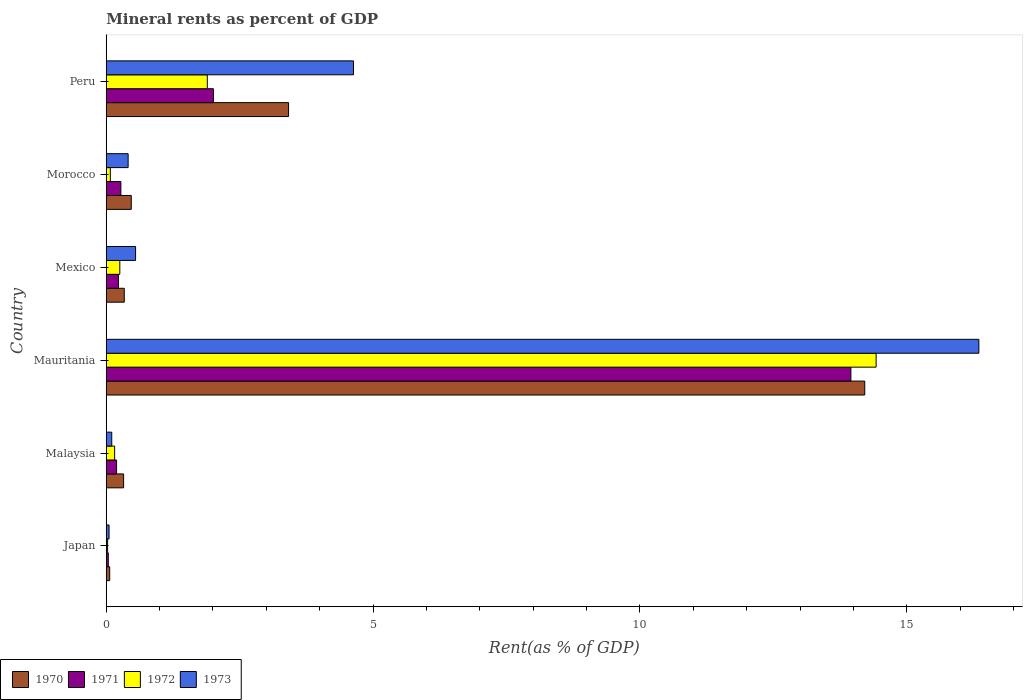Are the number of bars on each tick of the Y-axis equal?
Keep it short and to the point. Yes. How many bars are there on the 3rd tick from the top?
Ensure brevity in your answer.  4. How many bars are there on the 1st tick from the bottom?
Your answer should be very brief. 4. What is the label of the 4th group of bars from the top?
Provide a short and direct response. Mauritania. In how many cases, is the number of bars for a given country not equal to the number of legend labels?
Ensure brevity in your answer.  0. What is the mineral rent in 1972 in Mauritania?
Offer a terse response. 14.43. Across all countries, what is the maximum mineral rent in 1970?
Offer a very short reply. 14.21. Across all countries, what is the minimum mineral rent in 1971?
Make the answer very short. 0.04. In which country was the mineral rent in 1973 maximum?
Your answer should be very brief. Mauritania. What is the total mineral rent in 1971 in the graph?
Your answer should be compact. 16.7. What is the difference between the mineral rent in 1970 in Mauritania and that in Peru?
Your answer should be very brief. 10.8. What is the difference between the mineral rent in 1970 in Mauritania and the mineral rent in 1972 in Mexico?
Offer a terse response. 13.96. What is the average mineral rent in 1973 per country?
Provide a short and direct response. 3.68. What is the difference between the mineral rent in 1973 and mineral rent in 1972 in Mauritania?
Ensure brevity in your answer.  1.93. In how many countries, is the mineral rent in 1971 greater than 3 %?
Offer a terse response. 1. What is the ratio of the mineral rent in 1972 in Morocco to that in Peru?
Offer a very short reply. 0.04. Is the difference between the mineral rent in 1973 in Japan and Peru greater than the difference between the mineral rent in 1972 in Japan and Peru?
Give a very brief answer. No. What is the difference between the highest and the second highest mineral rent in 1971?
Your response must be concise. 11.94. What is the difference between the highest and the lowest mineral rent in 1972?
Your answer should be compact. 14.4. In how many countries, is the mineral rent in 1971 greater than the average mineral rent in 1971 taken over all countries?
Your response must be concise. 1. Is the sum of the mineral rent in 1971 in Mauritania and Peru greater than the maximum mineral rent in 1970 across all countries?
Offer a terse response. Yes. Is it the case that in every country, the sum of the mineral rent in 1972 and mineral rent in 1970 is greater than the sum of mineral rent in 1973 and mineral rent in 1971?
Make the answer very short. No. What does the 4th bar from the bottom in Mexico represents?
Your response must be concise. 1973. Are all the bars in the graph horizontal?
Offer a terse response. Yes. What is the difference between two consecutive major ticks on the X-axis?
Make the answer very short. 5. Does the graph contain grids?
Offer a terse response. No. What is the title of the graph?
Your answer should be very brief. Mineral rents as percent of GDP. Does "1977" appear as one of the legend labels in the graph?
Provide a short and direct response. No. What is the label or title of the X-axis?
Provide a short and direct response. Rent(as % of GDP). What is the label or title of the Y-axis?
Provide a short and direct response. Country. What is the Rent(as % of GDP) of 1970 in Japan?
Keep it short and to the point. 0.06. What is the Rent(as % of GDP) of 1971 in Japan?
Make the answer very short. 0.04. What is the Rent(as % of GDP) in 1972 in Japan?
Make the answer very short. 0.03. What is the Rent(as % of GDP) of 1973 in Japan?
Keep it short and to the point. 0.05. What is the Rent(as % of GDP) of 1970 in Malaysia?
Ensure brevity in your answer.  0.33. What is the Rent(as % of GDP) of 1971 in Malaysia?
Provide a short and direct response. 0.19. What is the Rent(as % of GDP) in 1972 in Malaysia?
Your answer should be compact. 0.16. What is the Rent(as % of GDP) in 1973 in Malaysia?
Offer a terse response. 0.1. What is the Rent(as % of GDP) of 1970 in Mauritania?
Offer a very short reply. 14.21. What is the Rent(as % of GDP) of 1971 in Mauritania?
Make the answer very short. 13.95. What is the Rent(as % of GDP) in 1972 in Mauritania?
Make the answer very short. 14.43. What is the Rent(as % of GDP) of 1973 in Mauritania?
Give a very brief answer. 16.35. What is the Rent(as % of GDP) of 1970 in Mexico?
Provide a succinct answer. 0.34. What is the Rent(as % of GDP) in 1971 in Mexico?
Your response must be concise. 0.23. What is the Rent(as % of GDP) of 1972 in Mexico?
Your answer should be compact. 0.25. What is the Rent(as % of GDP) of 1973 in Mexico?
Make the answer very short. 0.55. What is the Rent(as % of GDP) of 1970 in Morocco?
Your answer should be compact. 0.47. What is the Rent(as % of GDP) of 1971 in Morocco?
Keep it short and to the point. 0.27. What is the Rent(as % of GDP) of 1972 in Morocco?
Your answer should be very brief. 0.08. What is the Rent(as % of GDP) in 1973 in Morocco?
Offer a terse response. 0.41. What is the Rent(as % of GDP) of 1970 in Peru?
Give a very brief answer. 3.42. What is the Rent(as % of GDP) of 1971 in Peru?
Provide a succinct answer. 2.01. What is the Rent(as % of GDP) of 1972 in Peru?
Your answer should be very brief. 1.89. What is the Rent(as % of GDP) of 1973 in Peru?
Your answer should be compact. 4.63. Across all countries, what is the maximum Rent(as % of GDP) in 1970?
Keep it short and to the point. 14.21. Across all countries, what is the maximum Rent(as % of GDP) in 1971?
Provide a succinct answer. 13.95. Across all countries, what is the maximum Rent(as % of GDP) in 1972?
Keep it short and to the point. 14.43. Across all countries, what is the maximum Rent(as % of GDP) in 1973?
Provide a short and direct response. 16.35. Across all countries, what is the minimum Rent(as % of GDP) of 1970?
Your answer should be very brief. 0.06. Across all countries, what is the minimum Rent(as % of GDP) in 1971?
Your response must be concise. 0.04. Across all countries, what is the minimum Rent(as % of GDP) of 1972?
Provide a succinct answer. 0.03. Across all countries, what is the minimum Rent(as % of GDP) in 1973?
Your response must be concise. 0.05. What is the total Rent(as % of GDP) of 1970 in the graph?
Offer a terse response. 18.83. What is the total Rent(as % of GDP) in 1971 in the graph?
Your answer should be very brief. 16.7. What is the total Rent(as % of GDP) in 1972 in the graph?
Offer a very short reply. 16.83. What is the total Rent(as % of GDP) in 1973 in the graph?
Your response must be concise. 22.1. What is the difference between the Rent(as % of GDP) of 1970 in Japan and that in Malaysia?
Offer a very short reply. -0.26. What is the difference between the Rent(as % of GDP) in 1971 in Japan and that in Malaysia?
Your answer should be compact. -0.16. What is the difference between the Rent(as % of GDP) of 1972 in Japan and that in Malaysia?
Your response must be concise. -0.13. What is the difference between the Rent(as % of GDP) in 1973 in Japan and that in Malaysia?
Give a very brief answer. -0.05. What is the difference between the Rent(as % of GDP) of 1970 in Japan and that in Mauritania?
Your answer should be very brief. -14.15. What is the difference between the Rent(as % of GDP) of 1971 in Japan and that in Mauritania?
Your response must be concise. -13.91. What is the difference between the Rent(as % of GDP) in 1972 in Japan and that in Mauritania?
Your response must be concise. -14.4. What is the difference between the Rent(as % of GDP) in 1973 in Japan and that in Mauritania?
Your answer should be very brief. -16.3. What is the difference between the Rent(as % of GDP) in 1970 in Japan and that in Mexico?
Your answer should be very brief. -0.27. What is the difference between the Rent(as % of GDP) in 1971 in Japan and that in Mexico?
Offer a terse response. -0.19. What is the difference between the Rent(as % of GDP) of 1972 in Japan and that in Mexico?
Provide a short and direct response. -0.23. What is the difference between the Rent(as % of GDP) in 1973 in Japan and that in Mexico?
Your answer should be very brief. -0.5. What is the difference between the Rent(as % of GDP) in 1970 in Japan and that in Morocco?
Make the answer very short. -0.4. What is the difference between the Rent(as % of GDP) in 1971 in Japan and that in Morocco?
Keep it short and to the point. -0.24. What is the difference between the Rent(as % of GDP) of 1972 in Japan and that in Morocco?
Provide a succinct answer. -0.05. What is the difference between the Rent(as % of GDP) in 1973 in Japan and that in Morocco?
Keep it short and to the point. -0.36. What is the difference between the Rent(as % of GDP) in 1970 in Japan and that in Peru?
Your answer should be very brief. -3.35. What is the difference between the Rent(as % of GDP) in 1971 in Japan and that in Peru?
Your answer should be compact. -1.97. What is the difference between the Rent(as % of GDP) of 1972 in Japan and that in Peru?
Your answer should be compact. -1.87. What is the difference between the Rent(as % of GDP) in 1973 in Japan and that in Peru?
Provide a succinct answer. -4.58. What is the difference between the Rent(as % of GDP) in 1970 in Malaysia and that in Mauritania?
Your response must be concise. -13.89. What is the difference between the Rent(as % of GDP) of 1971 in Malaysia and that in Mauritania?
Offer a very short reply. -13.76. What is the difference between the Rent(as % of GDP) of 1972 in Malaysia and that in Mauritania?
Ensure brevity in your answer.  -14.27. What is the difference between the Rent(as % of GDP) of 1973 in Malaysia and that in Mauritania?
Your response must be concise. -16.25. What is the difference between the Rent(as % of GDP) in 1970 in Malaysia and that in Mexico?
Ensure brevity in your answer.  -0.01. What is the difference between the Rent(as % of GDP) of 1971 in Malaysia and that in Mexico?
Your answer should be compact. -0.03. What is the difference between the Rent(as % of GDP) of 1972 in Malaysia and that in Mexico?
Keep it short and to the point. -0.1. What is the difference between the Rent(as % of GDP) of 1973 in Malaysia and that in Mexico?
Provide a succinct answer. -0.45. What is the difference between the Rent(as % of GDP) of 1970 in Malaysia and that in Morocco?
Give a very brief answer. -0.14. What is the difference between the Rent(as % of GDP) in 1971 in Malaysia and that in Morocco?
Offer a very short reply. -0.08. What is the difference between the Rent(as % of GDP) of 1972 in Malaysia and that in Morocco?
Your answer should be very brief. 0.08. What is the difference between the Rent(as % of GDP) of 1973 in Malaysia and that in Morocco?
Your response must be concise. -0.31. What is the difference between the Rent(as % of GDP) of 1970 in Malaysia and that in Peru?
Provide a succinct answer. -3.09. What is the difference between the Rent(as % of GDP) in 1971 in Malaysia and that in Peru?
Provide a short and direct response. -1.81. What is the difference between the Rent(as % of GDP) of 1972 in Malaysia and that in Peru?
Ensure brevity in your answer.  -1.74. What is the difference between the Rent(as % of GDP) of 1973 in Malaysia and that in Peru?
Ensure brevity in your answer.  -4.53. What is the difference between the Rent(as % of GDP) of 1970 in Mauritania and that in Mexico?
Give a very brief answer. 13.88. What is the difference between the Rent(as % of GDP) in 1971 in Mauritania and that in Mexico?
Your answer should be compact. 13.72. What is the difference between the Rent(as % of GDP) of 1972 in Mauritania and that in Mexico?
Your answer should be very brief. 14.17. What is the difference between the Rent(as % of GDP) in 1973 in Mauritania and that in Mexico?
Offer a terse response. 15.8. What is the difference between the Rent(as % of GDP) in 1970 in Mauritania and that in Morocco?
Provide a succinct answer. 13.74. What is the difference between the Rent(as % of GDP) in 1971 in Mauritania and that in Morocco?
Ensure brevity in your answer.  13.68. What is the difference between the Rent(as % of GDP) in 1972 in Mauritania and that in Morocco?
Your answer should be compact. 14.35. What is the difference between the Rent(as % of GDP) of 1973 in Mauritania and that in Morocco?
Your answer should be very brief. 15.94. What is the difference between the Rent(as % of GDP) of 1970 in Mauritania and that in Peru?
Your answer should be very brief. 10.8. What is the difference between the Rent(as % of GDP) in 1971 in Mauritania and that in Peru?
Your answer should be compact. 11.94. What is the difference between the Rent(as % of GDP) in 1972 in Mauritania and that in Peru?
Offer a very short reply. 12.53. What is the difference between the Rent(as % of GDP) in 1973 in Mauritania and that in Peru?
Ensure brevity in your answer.  11.72. What is the difference between the Rent(as % of GDP) in 1970 in Mexico and that in Morocco?
Offer a terse response. -0.13. What is the difference between the Rent(as % of GDP) of 1971 in Mexico and that in Morocco?
Your response must be concise. -0.05. What is the difference between the Rent(as % of GDP) of 1972 in Mexico and that in Morocco?
Offer a terse response. 0.18. What is the difference between the Rent(as % of GDP) of 1973 in Mexico and that in Morocco?
Your answer should be very brief. 0.14. What is the difference between the Rent(as % of GDP) of 1970 in Mexico and that in Peru?
Provide a succinct answer. -3.08. What is the difference between the Rent(as % of GDP) in 1971 in Mexico and that in Peru?
Offer a terse response. -1.78. What is the difference between the Rent(as % of GDP) of 1972 in Mexico and that in Peru?
Give a very brief answer. -1.64. What is the difference between the Rent(as % of GDP) of 1973 in Mexico and that in Peru?
Make the answer very short. -4.08. What is the difference between the Rent(as % of GDP) in 1970 in Morocco and that in Peru?
Provide a succinct answer. -2.95. What is the difference between the Rent(as % of GDP) of 1971 in Morocco and that in Peru?
Give a very brief answer. -1.73. What is the difference between the Rent(as % of GDP) in 1972 in Morocco and that in Peru?
Your response must be concise. -1.82. What is the difference between the Rent(as % of GDP) in 1973 in Morocco and that in Peru?
Keep it short and to the point. -4.22. What is the difference between the Rent(as % of GDP) in 1970 in Japan and the Rent(as % of GDP) in 1971 in Malaysia?
Offer a very short reply. -0.13. What is the difference between the Rent(as % of GDP) in 1970 in Japan and the Rent(as % of GDP) in 1972 in Malaysia?
Your answer should be very brief. -0.09. What is the difference between the Rent(as % of GDP) in 1970 in Japan and the Rent(as % of GDP) in 1973 in Malaysia?
Your response must be concise. -0.04. What is the difference between the Rent(as % of GDP) in 1971 in Japan and the Rent(as % of GDP) in 1972 in Malaysia?
Provide a succinct answer. -0.12. What is the difference between the Rent(as % of GDP) of 1971 in Japan and the Rent(as % of GDP) of 1973 in Malaysia?
Provide a succinct answer. -0.06. What is the difference between the Rent(as % of GDP) of 1972 in Japan and the Rent(as % of GDP) of 1973 in Malaysia?
Give a very brief answer. -0.08. What is the difference between the Rent(as % of GDP) of 1970 in Japan and the Rent(as % of GDP) of 1971 in Mauritania?
Make the answer very short. -13.89. What is the difference between the Rent(as % of GDP) of 1970 in Japan and the Rent(as % of GDP) of 1972 in Mauritania?
Make the answer very short. -14.36. What is the difference between the Rent(as % of GDP) of 1970 in Japan and the Rent(as % of GDP) of 1973 in Mauritania?
Give a very brief answer. -16.29. What is the difference between the Rent(as % of GDP) in 1971 in Japan and the Rent(as % of GDP) in 1972 in Mauritania?
Offer a very short reply. -14.39. What is the difference between the Rent(as % of GDP) in 1971 in Japan and the Rent(as % of GDP) in 1973 in Mauritania?
Your answer should be compact. -16.31. What is the difference between the Rent(as % of GDP) of 1972 in Japan and the Rent(as % of GDP) of 1973 in Mauritania?
Ensure brevity in your answer.  -16.33. What is the difference between the Rent(as % of GDP) in 1970 in Japan and the Rent(as % of GDP) in 1971 in Mexico?
Your response must be concise. -0.16. What is the difference between the Rent(as % of GDP) in 1970 in Japan and the Rent(as % of GDP) in 1972 in Mexico?
Your response must be concise. -0.19. What is the difference between the Rent(as % of GDP) of 1970 in Japan and the Rent(as % of GDP) of 1973 in Mexico?
Your response must be concise. -0.48. What is the difference between the Rent(as % of GDP) in 1971 in Japan and the Rent(as % of GDP) in 1972 in Mexico?
Provide a succinct answer. -0.22. What is the difference between the Rent(as % of GDP) of 1971 in Japan and the Rent(as % of GDP) of 1973 in Mexico?
Offer a terse response. -0.51. What is the difference between the Rent(as % of GDP) in 1972 in Japan and the Rent(as % of GDP) in 1973 in Mexico?
Keep it short and to the point. -0.52. What is the difference between the Rent(as % of GDP) of 1970 in Japan and the Rent(as % of GDP) of 1971 in Morocco?
Give a very brief answer. -0.21. What is the difference between the Rent(as % of GDP) of 1970 in Japan and the Rent(as % of GDP) of 1972 in Morocco?
Provide a short and direct response. -0.01. What is the difference between the Rent(as % of GDP) of 1970 in Japan and the Rent(as % of GDP) of 1973 in Morocco?
Your response must be concise. -0.35. What is the difference between the Rent(as % of GDP) of 1971 in Japan and the Rent(as % of GDP) of 1972 in Morocco?
Provide a short and direct response. -0.04. What is the difference between the Rent(as % of GDP) of 1971 in Japan and the Rent(as % of GDP) of 1973 in Morocco?
Provide a succinct answer. -0.37. What is the difference between the Rent(as % of GDP) in 1972 in Japan and the Rent(as % of GDP) in 1973 in Morocco?
Provide a succinct answer. -0.39. What is the difference between the Rent(as % of GDP) in 1970 in Japan and the Rent(as % of GDP) in 1971 in Peru?
Make the answer very short. -1.94. What is the difference between the Rent(as % of GDP) of 1970 in Japan and the Rent(as % of GDP) of 1972 in Peru?
Offer a terse response. -1.83. What is the difference between the Rent(as % of GDP) in 1970 in Japan and the Rent(as % of GDP) in 1973 in Peru?
Provide a succinct answer. -4.57. What is the difference between the Rent(as % of GDP) in 1971 in Japan and the Rent(as % of GDP) in 1972 in Peru?
Your response must be concise. -1.86. What is the difference between the Rent(as % of GDP) in 1971 in Japan and the Rent(as % of GDP) in 1973 in Peru?
Keep it short and to the point. -4.59. What is the difference between the Rent(as % of GDP) of 1972 in Japan and the Rent(as % of GDP) of 1973 in Peru?
Your response must be concise. -4.61. What is the difference between the Rent(as % of GDP) of 1970 in Malaysia and the Rent(as % of GDP) of 1971 in Mauritania?
Offer a terse response. -13.63. What is the difference between the Rent(as % of GDP) in 1970 in Malaysia and the Rent(as % of GDP) in 1972 in Mauritania?
Your response must be concise. -14.1. What is the difference between the Rent(as % of GDP) of 1970 in Malaysia and the Rent(as % of GDP) of 1973 in Mauritania?
Offer a very short reply. -16.03. What is the difference between the Rent(as % of GDP) of 1971 in Malaysia and the Rent(as % of GDP) of 1972 in Mauritania?
Make the answer very short. -14.23. What is the difference between the Rent(as % of GDP) of 1971 in Malaysia and the Rent(as % of GDP) of 1973 in Mauritania?
Keep it short and to the point. -16.16. What is the difference between the Rent(as % of GDP) of 1972 in Malaysia and the Rent(as % of GDP) of 1973 in Mauritania?
Your answer should be very brief. -16.19. What is the difference between the Rent(as % of GDP) in 1970 in Malaysia and the Rent(as % of GDP) in 1971 in Mexico?
Ensure brevity in your answer.  0.1. What is the difference between the Rent(as % of GDP) of 1970 in Malaysia and the Rent(as % of GDP) of 1972 in Mexico?
Your response must be concise. 0.07. What is the difference between the Rent(as % of GDP) in 1970 in Malaysia and the Rent(as % of GDP) in 1973 in Mexico?
Ensure brevity in your answer.  -0.22. What is the difference between the Rent(as % of GDP) of 1971 in Malaysia and the Rent(as % of GDP) of 1972 in Mexico?
Offer a very short reply. -0.06. What is the difference between the Rent(as % of GDP) of 1971 in Malaysia and the Rent(as % of GDP) of 1973 in Mexico?
Your response must be concise. -0.36. What is the difference between the Rent(as % of GDP) in 1972 in Malaysia and the Rent(as % of GDP) in 1973 in Mexico?
Give a very brief answer. -0.39. What is the difference between the Rent(as % of GDP) of 1970 in Malaysia and the Rent(as % of GDP) of 1971 in Morocco?
Offer a terse response. 0.05. What is the difference between the Rent(as % of GDP) of 1970 in Malaysia and the Rent(as % of GDP) of 1972 in Morocco?
Your answer should be very brief. 0.25. What is the difference between the Rent(as % of GDP) of 1970 in Malaysia and the Rent(as % of GDP) of 1973 in Morocco?
Ensure brevity in your answer.  -0.09. What is the difference between the Rent(as % of GDP) in 1971 in Malaysia and the Rent(as % of GDP) in 1972 in Morocco?
Provide a short and direct response. 0.12. What is the difference between the Rent(as % of GDP) of 1971 in Malaysia and the Rent(as % of GDP) of 1973 in Morocco?
Give a very brief answer. -0.22. What is the difference between the Rent(as % of GDP) in 1972 in Malaysia and the Rent(as % of GDP) in 1973 in Morocco?
Your answer should be very brief. -0.25. What is the difference between the Rent(as % of GDP) in 1970 in Malaysia and the Rent(as % of GDP) in 1971 in Peru?
Ensure brevity in your answer.  -1.68. What is the difference between the Rent(as % of GDP) of 1970 in Malaysia and the Rent(as % of GDP) of 1972 in Peru?
Your answer should be compact. -1.57. What is the difference between the Rent(as % of GDP) of 1970 in Malaysia and the Rent(as % of GDP) of 1973 in Peru?
Provide a short and direct response. -4.31. What is the difference between the Rent(as % of GDP) of 1971 in Malaysia and the Rent(as % of GDP) of 1972 in Peru?
Offer a terse response. -1.7. What is the difference between the Rent(as % of GDP) of 1971 in Malaysia and the Rent(as % of GDP) of 1973 in Peru?
Your answer should be compact. -4.44. What is the difference between the Rent(as % of GDP) in 1972 in Malaysia and the Rent(as % of GDP) in 1973 in Peru?
Give a very brief answer. -4.48. What is the difference between the Rent(as % of GDP) in 1970 in Mauritania and the Rent(as % of GDP) in 1971 in Mexico?
Keep it short and to the point. 13.98. What is the difference between the Rent(as % of GDP) of 1970 in Mauritania and the Rent(as % of GDP) of 1972 in Mexico?
Your answer should be very brief. 13.96. What is the difference between the Rent(as % of GDP) in 1970 in Mauritania and the Rent(as % of GDP) in 1973 in Mexico?
Your answer should be compact. 13.66. What is the difference between the Rent(as % of GDP) in 1971 in Mauritania and the Rent(as % of GDP) in 1972 in Mexico?
Your answer should be very brief. 13.7. What is the difference between the Rent(as % of GDP) in 1971 in Mauritania and the Rent(as % of GDP) in 1973 in Mexico?
Keep it short and to the point. 13.4. What is the difference between the Rent(as % of GDP) of 1972 in Mauritania and the Rent(as % of GDP) of 1973 in Mexico?
Your answer should be compact. 13.88. What is the difference between the Rent(as % of GDP) in 1970 in Mauritania and the Rent(as % of GDP) in 1971 in Morocco?
Give a very brief answer. 13.94. What is the difference between the Rent(as % of GDP) in 1970 in Mauritania and the Rent(as % of GDP) in 1972 in Morocco?
Provide a succinct answer. 14.14. What is the difference between the Rent(as % of GDP) of 1970 in Mauritania and the Rent(as % of GDP) of 1973 in Morocco?
Give a very brief answer. 13.8. What is the difference between the Rent(as % of GDP) in 1971 in Mauritania and the Rent(as % of GDP) in 1972 in Morocco?
Your response must be concise. 13.88. What is the difference between the Rent(as % of GDP) of 1971 in Mauritania and the Rent(as % of GDP) of 1973 in Morocco?
Your answer should be compact. 13.54. What is the difference between the Rent(as % of GDP) in 1972 in Mauritania and the Rent(as % of GDP) in 1973 in Morocco?
Your answer should be compact. 14.02. What is the difference between the Rent(as % of GDP) in 1970 in Mauritania and the Rent(as % of GDP) in 1971 in Peru?
Your response must be concise. 12.2. What is the difference between the Rent(as % of GDP) in 1970 in Mauritania and the Rent(as % of GDP) in 1972 in Peru?
Make the answer very short. 12.32. What is the difference between the Rent(as % of GDP) in 1970 in Mauritania and the Rent(as % of GDP) in 1973 in Peru?
Provide a short and direct response. 9.58. What is the difference between the Rent(as % of GDP) of 1971 in Mauritania and the Rent(as % of GDP) of 1972 in Peru?
Give a very brief answer. 12.06. What is the difference between the Rent(as % of GDP) in 1971 in Mauritania and the Rent(as % of GDP) in 1973 in Peru?
Provide a succinct answer. 9.32. What is the difference between the Rent(as % of GDP) in 1972 in Mauritania and the Rent(as % of GDP) in 1973 in Peru?
Give a very brief answer. 9.79. What is the difference between the Rent(as % of GDP) in 1970 in Mexico and the Rent(as % of GDP) in 1971 in Morocco?
Your answer should be compact. 0.06. What is the difference between the Rent(as % of GDP) of 1970 in Mexico and the Rent(as % of GDP) of 1972 in Morocco?
Offer a terse response. 0.26. What is the difference between the Rent(as % of GDP) of 1970 in Mexico and the Rent(as % of GDP) of 1973 in Morocco?
Offer a terse response. -0.07. What is the difference between the Rent(as % of GDP) in 1971 in Mexico and the Rent(as % of GDP) in 1972 in Morocco?
Make the answer very short. 0.15. What is the difference between the Rent(as % of GDP) of 1971 in Mexico and the Rent(as % of GDP) of 1973 in Morocco?
Ensure brevity in your answer.  -0.18. What is the difference between the Rent(as % of GDP) of 1972 in Mexico and the Rent(as % of GDP) of 1973 in Morocco?
Offer a terse response. -0.16. What is the difference between the Rent(as % of GDP) in 1970 in Mexico and the Rent(as % of GDP) in 1971 in Peru?
Make the answer very short. -1.67. What is the difference between the Rent(as % of GDP) in 1970 in Mexico and the Rent(as % of GDP) in 1972 in Peru?
Give a very brief answer. -1.56. What is the difference between the Rent(as % of GDP) in 1970 in Mexico and the Rent(as % of GDP) in 1973 in Peru?
Your response must be concise. -4.29. What is the difference between the Rent(as % of GDP) of 1971 in Mexico and the Rent(as % of GDP) of 1972 in Peru?
Provide a succinct answer. -1.67. What is the difference between the Rent(as % of GDP) of 1971 in Mexico and the Rent(as % of GDP) of 1973 in Peru?
Ensure brevity in your answer.  -4.4. What is the difference between the Rent(as % of GDP) in 1972 in Mexico and the Rent(as % of GDP) in 1973 in Peru?
Your answer should be very brief. -4.38. What is the difference between the Rent(as % of GDP) in 1970 in Morocco and the Rent(as % of GDP) in 1971 in Peru?
Your response must be concise. -1.54. What is the difference between the Rent(as % of GDP) in 1970 in Morocco and the Rent(as % of GDP) in 1972 in Peru?
Your answer should be compact. -1.43. What is the difference between the Rent(as % of GDP) in 1970 in Morocco and the Rent(as % of GDP) in 1973 in Peru?
Provide a succinct answer. -4.16. What is the difference between the Rent(as % of GDP) of 1971 in Morocco and the Rent(as % of GDP) of 1972 in Peru?
Keep it short and to the point. -1.62. What is the difference between the Rent(as % of GDP) in 1971 in Morocco and the Rent(as % of GDP) in 1973 in Peru?
Keep it short and to the point. -4.36. What is the difference between the Rent(as % of GDP) of 1972 in Morocco and the Rent(as % of GDP) of 1973 in Peru?
Provide a short and direct response. -4.56. What is the average Rent(as % of GDP) in 1970 per country?
Ensure brevity in your answer.  3.14. What is the average Rent(as % of GDP) in 1971 per country?
Provide a succinct answer. 2.78. What is the average Rent(as % of GDP) in 1972 per country?
Ensure brevity in your answer.  2.81. What is the average Rent(as % of GDP) in 1973 per country?
Provide a short and direct response. 3.68. What is the difference between the Rent(as % of GDP) in 1970 and Rent(as % of GDP) in 1971 in Japan?
Offer a very short reply. 0.03. What is the difference between the Rent(as % of GDP) in 1970 and Rent(as % of GDP) in 1972 in Japan?
Make the answer very short. 0.04. What is the difference between the Rent(as % of GDP) of 1970 and Rent(as % of GDP) of 1973 in Japan?
Provide a succinct answer. 0.01. What is the difference between the Rent(as % of GDP) of 1971 and Rent(as % of GDP) of 1972 in Japan?
Your answer should be very brief. 0.01. What is the difference between the Rent(as % of GDP) of 1971 and Rent(as % of GDP) of 1973 in Japan?
Provide a short and direct response. -0.01. What is the difference between the Rent(as % of GDP) in 1972 and Rent(as % of GDP) in 1973 in Japan?
Provide a succinct answer. -0.03. What is the difference between the Rent(as % of GDP) in 1970 and Rent(as % of GDP) in 1971 in Malaysia?
Your answer should be compact. 0.13. What is the difference between the Rent(as % of GDP) in 1970 and Rent(as % of GDP) in 1972 in Malaysia?
Make the answer very short. 0.17. What is the difference between the Rent(as % of GDP) of 1970 and Rent(as % of GDP) of 1973 in Malaysia?
Keep it short and to the point. 0.22. What is the difference between the Rent(as % of GDP) of 1971 and Rent(as % of GDP) of 1972 in Malaysia?
Provide a succinct answer. 0.04. What is the difference between the Rent(as % of GDP) in 1971 and Rent(as % of GDP) in 1973 in Malaysia?
Provide a short and direct response. 0.09. What is the difference between the Rent(as % of GDP) of 1972 and Rent(as % of GDP) of 1973 in Malaysia?
Provide a succinct answer. 0.05. What is the difference between the Rent(as % of GDP) of 1970 and Rent(as % of GDP) of 1971 in Mauritania?
Offer a terse response. 0.26. What is the difference between the Rent(as % of GDP) of 1970 and Rent(as % of GDP) of 1972 in Mauritania?
Provide a short and direct response. -0.21. What is the difference between the Rent(as % of GDP) in 1970 and Rent(as % of GDP) in 1973 in Mauritania?
Make the answer very short. -2.14. What is the difference between the Rent(as % of GDP) in 1971 and Rent(as % of GDP) in 1972 in Mauritania?
Your answer should be compact. -0.47. What is the difference between the Rent(as % of GDP) of 1971 and Rent(as % of GDP) of 1973 in Mauritania?
Provide a short and direct response. -2.4. What is the difference between the Rent(as % of GDP) in 1972 and Rent(as % of GDP) in 1973 in Mauritania?
Provide a succinct answer. -1.93. What is the difference between the Rent(as % of GDP) in 1970 and Rent(as % of GDP) in 1971 in Mexico?
Your response must be concise. 0.11. What is the difference between the Rent(as % of GDP) in 1970 and Rent(as % of GDP) in 1972 in Mexico?
Keep it short and to the point. 0.08. What is the difference between the Rent(as % of GDP) of 1970 and Rent(as % of GDP) of 1973 in Mexico?
Make the answer very short. -0.21. What is the difference between the Rent(as % of GDP) in 1971 and Rent(as % of GDP) in 1972 in Mexico?
Provide a short and direct response. -0.03. What is the difference between the Rent(as % of GDP) of 1971 and Rent(as % of GDP) of 1973 in Mexico?
Provide a short and direct response. -0.32. What is the difference between the Rent(as % of GDP) in 1972 and Rent(as % of GDP) in 1973 in Mexico?
Offer a very short reply. -0.3. What is the difference between the Rent(as % of GDP) in 1970 and Rent(as % of GDP) in 1971 in Morocco?
Your response must be concise. 0.19. What is the difference between the Rent(as % of GDP) of 1970 and Rent(as % of GDP) of 1972 in Morocco?
Give a very brief answer. 0.39. What is the difference between the Rent(as % of GDP) of 1970 and Rent(as % of GDP) of 1973 in Morocco?
Your answer should be compact. 0.06. What is the difference between the Rent(as % of GDP) in 1971 and Rent(as % of GDP) in 1972 in Morocco?
Keep it short and to the point. 0.2. What is the difference between the Rent(as % of GDP) of 1971 and Rent(as % of GDP) of 1973 in Morocco?
Give a very brief answer. -0.14. What is the difference between the Rent(as % of GDP) in 1972 and Rent(as % of GDP) in 1973 in Morocco?
Make the answer very short. -0.33. What is the difference between the Rent(as % of GDP) of 1970 and Rent(as % of GDP) of 1971 in Peru?
Keep it short and to the point. 1.41. What is the difference between the Rent(as % of GDP) of 1970 and Rent(as % of GDP) of 1972 in Peru?
Keep it short and to the point. 1.52. What is the difference between the Rent(as % of GDP) in 1970 and Rent(as % of GDP) in 1973 in Peru?
Your response must be concise. -1.22. What is the difference between the Rent(as % of GDP) of 1971 and Rent(as % of GDP) of 1972 in Peru?
Provide a short and direct response. 0.11. What is the difference between the Rent(as % of GDP) of 1971 and Rent(as % of GDP) of 1973 in Peru?
Ensure brevity in your answer.  -2.62. What is the difference between the Rent(as % of GDP) in 1972 and Rent(as % of GDP) in 1973 in Peru?
Offer a terse response. -2.74. What is the ratio of the Rent(as % of GDP) in 1970 in Japan to that in Malaysia?
Give a very brief answer. 0.2. What is the ratio of the Rent(as % of GDP) of 1971 in Japan to that in Malaysia?
Offer a very short reply. 0.2. What is the ratio of the Rent(as % of GDP) in 1972 in Japan to that in Malaysia?
Make the answer very short. 0.16. What is the ratio of the Rent(as % of GDP) of 1973 in Japan to that in Malaysia?
Make the answer very short. 0.51. What is the ratio of the Rent(as % of GDP) of 1970 in Japan to that in Mauritania?
Keep it short and to the point. 0. What is the ratio of the Rent(as % of GDP) of 1971 in Japan to that in Mauritania?
Provide a short and direct response. 0. What is the ratio of the Rent(as % of GDP) in 1972 in Japan to that in Mauritania?
Offer a terse response. 0. What is the ratio of the Rent(as % of GDP) of 1973 in Japan to that in Mauritania?
Your answer should be compact. 0. What is the ratio of the Rent(as % of GDP) in 1970 in Japan to that in Mexico?
Your answer should be very brief. 0.19. What is the ratio of the Rent(as % of GDP) in 1971 in Japan to that in Mexico?
Provide a succinct answer. 0.17. What is the ratio of the Rent(as % of GDP) in 1972 in Japan to that in Mexico?
Provide a short and direct response. 0.1. What is the ratio of the Rent(as % of GDP) of 1973 in Japan to that in Mexico?
Your response must be concise. 0.1. What is the ratio of the Rent(as % of GDP) in 1970 in Japan to that in Morocco?
Give a very brief answer. 0.14. What is the ratio of the Rent(as % of GDP) in 1971 in Japan to that in Morocco?
Your response must be concise. 0.14. What is the ratio of the Rent(as % of GDP) of 1972 in Japan to that in Morocco?
Give a very brief answer. 0.33. What is the ratio of the Rent(as % of GDP) of 1973 in Japan to that in Morocco?
Your answer should be very brief. 0.13. What is the ratio of the Rent(as % of GDP) of 1970 in Japan to that in Peru?
Offer a terse response. 0.02. What is the ratio of the Rent(as % of GDP) of 1971 in Japan to that in Peru?
Provide a succinct answer. 0.02. What is the ratio of the Rent(as % of GDP) of 1972 in Japan to that in Peru?
Offer a terse response. 0.01. What is the ratio of the Rent(as % of GDP) of 1973 in Japan to that in Peru?
Your response must be concise. 0.01. What is the ratio of the Rent(as % of GDP) of 1970 in Malaysia to that in Mauritania?
Give a very brief answer. 0.02. What is the ratio of the Rent(as % of GDP) in 1971 in Malaysia to that in Mauritania?
Ensure brevity in your answer.  0.01. What is the ratio of the Rent(as % of GDP) of 1972 in Malaysia to that in Mauritania?
Your answer should be compact. 0.01. What is the ratio of the Rent(as % of GDP) of 1973 in Malaysia to that in Mauritania?
Your answer should be very brief. 0.01. What is the ratio of the Rent(as % of GDP) of 1970 in Malaysia to that in Mexico?
Your answer should be compact. 0.96. What is the ratio of the Rent(as % of GDP) of 1971 in Malaysia to that in Mexico?
Your answer should be compact. 0.85. What is the ratio of the Rent(as % of GDP) in 1972 in Malaysia to that in Mexico?
Your answer should be very brief. 0.62. What is the ratio of the Rent(as % of GDP) of 1973 in Malaysia to that in Mexico?
Your response must be concise. 0.19. What is the ratio of the Rent(as % of GDP) of 1970 in Malaysia to that in Morocco?
Provide a short and direct response. 0.69. What is the ratio of the Rent(as % of GDP) in 1971 in Malaysia to that in Morocco?
Offer a very short reply. 0.71. What is the ratio of the Rent(as % of GDP) in 1972 in Malaysia to that in Morocco?
Offer a very short reply. 2.04. What is the ratio of the Rent(as % of GDP) in 1973 in Malaysia to that in Morocco?
Provide a short and direct response. 0.25. What is the ratio of the Rent(as % of GDP) in 1970 in Malaysia to that in Peru?
Offer a terse response. 0.1. What is the ratio of the Rent(as % of GDP) in 1971 in Malaysia to that in Peru?
Provide a succinct answer. 0.1. What is the ratio of the Rent(as % of GDP) of 1972 in Malaysia to that in Peru?
Ensure brevity in your answer.  0.08. What is the ratio of the Rent(as % of GDP) of 1973 in Malaysia to that in Peru?
Provide a succinct answer. 0.02. What is the ratio of the Rent(as % of GDP) in 1970 in Mauritania to that in Mexico?
Provide a short and direct response. 42.1. What is the ratio of the Rent(as % of GDP) of 1971 in Mauritania to that in Mexico?
Your answer should be very brief. 61.1. What is the ratio of the Rent(as % of GDP) in 1972 in Mauritania to that in Mexico?
Make the answer very short. 56.78. What is the ratio of the Rent(as % of GDP) in 1973 in Mauritania to that in Mexico?
Keep it short and to the point. 29.75. What is the ratio of the Rent(as % of GDP) of 1970 in Mauritania to that in Morocco?
Your answer should be compact. 30.32. What is the ratio of the Rent(as % of GDP) in 1971 in Mauritania to that in Morocco?
Offer a very short reply. 50.9. What is the ratio of the Rent(as % of GDP) of 1972 in Mauritania to that in Morocco?
Provide a short and direct response. 187.82. What is the ratio of the Rent(as % of GDP) of 1973 in Mauritania to that in Morocco?
Ensure brevity in your answer.  39.85. What is the ratio of the Rent(as % of GDP) of 1970 in Mauritania to that in Peru?
Give a very brief answer. 4.16. What is the ratio of the Rent(as % of GDP) of 1971 in Mauritania to that in Peru?
Offer a very short reply. 6.95. What is the ratio of the Rent(as % of GDP) in 1972 in Mauritania to that in Peru?
Make the answer very short. 7.62. What is the ratio of the Rent(as % of GDP) in 1973 in Mauritania to that in Peru?
Your answer should be very brief. 3.53. What is the ratio of the Rent(as % of GDP) of 1970 in Mexico to that in Morocco?
Offer a very short reply. 0.72. What is the ratio of the Rent(as % of GDP) of 1971 in Mexico to that in Morocco?
Your response must be concise. 0.83. What is the ratio of the Rent(as % of GDP) in 1972 in Mexico to that in Morocco?
Your answer should be very brief. 3.31. What is the ratio of the Rent(as % of GDP) in 1973 in Mexico to that in Morocco?
Offer a terse response. 1.34. What is the ratio of the Rent(as % of GDP) in 1970 in Mexico to that in Peru?
Your answer should be compact. 0.1. What is the ratio of the Rent(as % of GDP) in 1971 in Mexico to that in Peru?
Make the answer very short. 0.11. What is the ratio of the Rent(as % of GDP) in 1972 in Mexico to that in Peru?
Your answer should be compact. 0.13. What is the ratio of the Rent(as % of GDP) of 1973 in Mexico to that in Peru?
Make the answer very short. 0.12. What is the ratio of the Rent(as % of GDP) of 1970 in Morocco to that in Peru?
Ensure brevity in your answer.  0.14. What is the ratio of the Rent(as % of GDP) in 1971 in Morocco to that in Peru?
Provide a short and direct response. 0.14. What is the ratio of the Rent(as % of GDP) of 1972 in Morocco to that in Peru?
Your answer should be compact. 0.04. What is the ratio of the Rent(as % of GDP) in 1973 in Morocco to that in Peru?
Provide a short and direct response. 0.09. What is the difference between the highest and the second highest Rent(as % of GDP) of 1970?
Give a very brief answer. 10.8. What is the difference between the highest and the second highest Rent(as % of GDP) in 1971?
Offer a very short reply. 11.94. What is the difference between the highest and the second highest Rent(as % of GDP) of 1972?
Offer a terse response. 12.53. What is the difference between the highest and the second highest Rent(as % of GDP) of 1973?
Keep it short and to the point. 11.72. What is the difference between the highest and the lowest Rent(as % of GDP) of 1970?
Offer a very short reply. 14.15. What is the difference between the highest and the lowest Rent(as % of GDP) in 1971?
Your answer should be very brief. 13.91. What is the difference between the highest and the lowest Rent(as % of GDP) of 1972?
Keep it short and to the point. 14.4. What is the difference between the highest and the lowest Rent(as % of GDP) in 1973?
Offer a terse response. 16.3. 